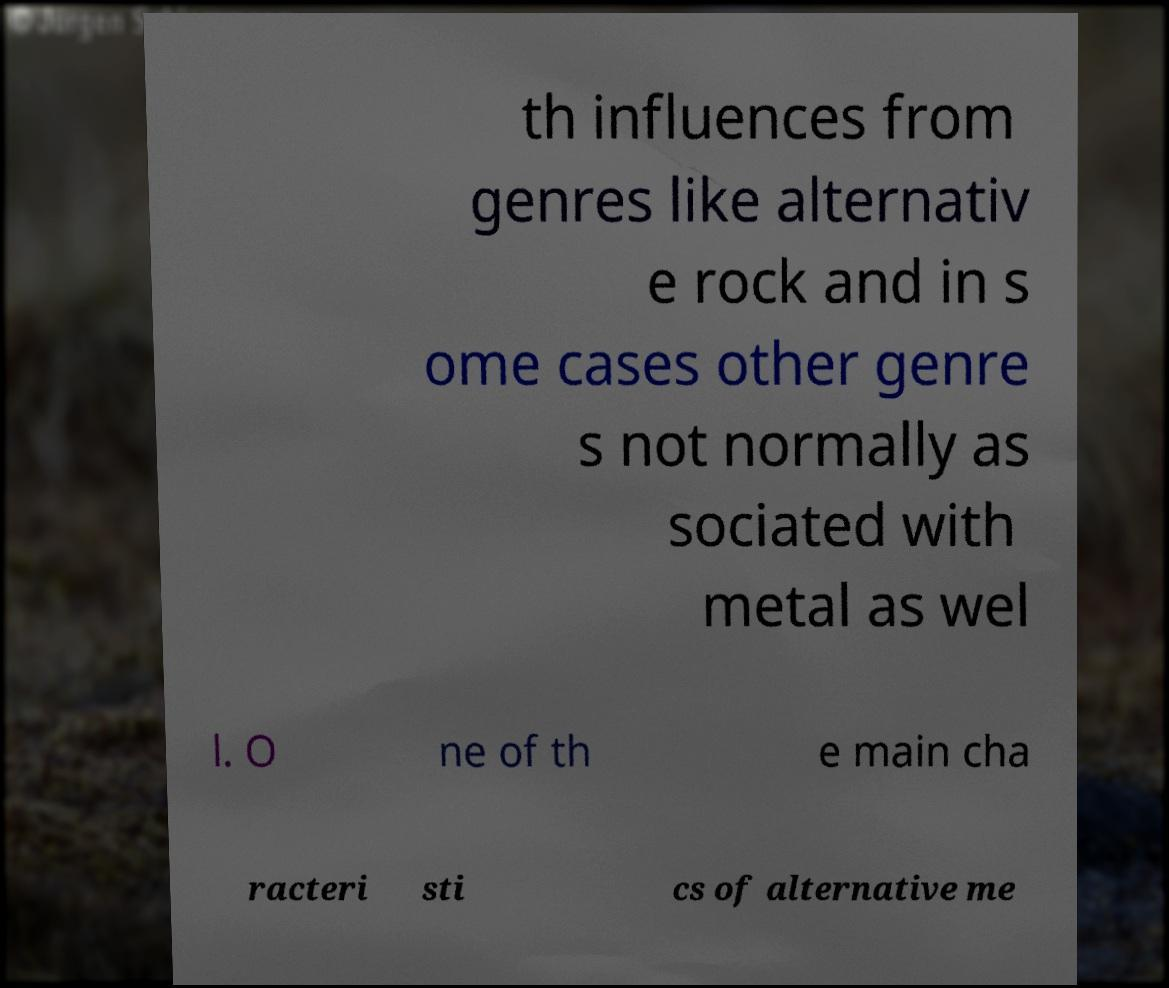For documentation purposes, I need the text within this image transcribed. Could you provide that? th influences from genres like alternativ e rock and in s ome cases other genre s not normally as sociated with metal as wel l. O ne of th e main cha racteri sti cs of alternative me 